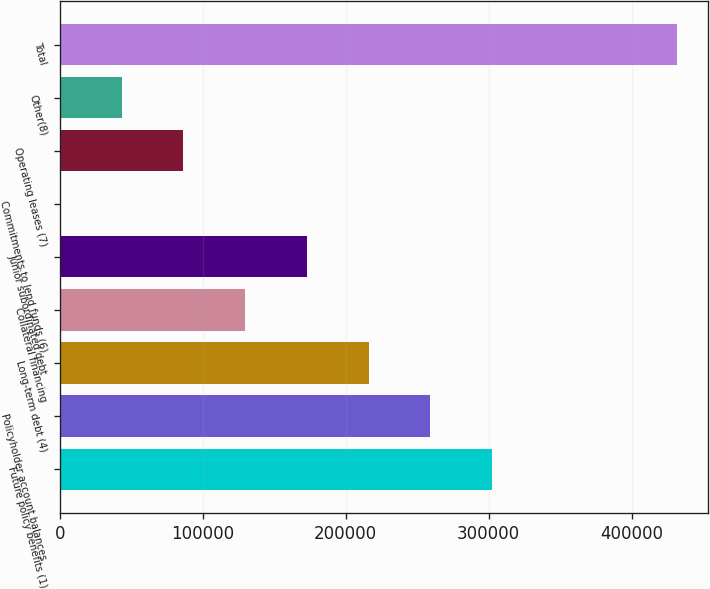<chart> <loc_0><loc_0><loc_500><loc_500><bar_chart><fcel>Future policy benefits (1)<fcel>Policyholder account balances<fcel>Long-term debt (4)<fcel>Collateral financing<fcel>Junior subordinated debt<fcel>Commitments to lend funds (6)<fcel>Operating leases (7)<fcel>Other(8)<fcel>Total<nl><fcel>302403<fcel>259207<fcel>216012<fcel>129620<fcel>172816<fcel>32<fcel>86423.8<fcel>43227.9<fcel>431991<nl></chart> 